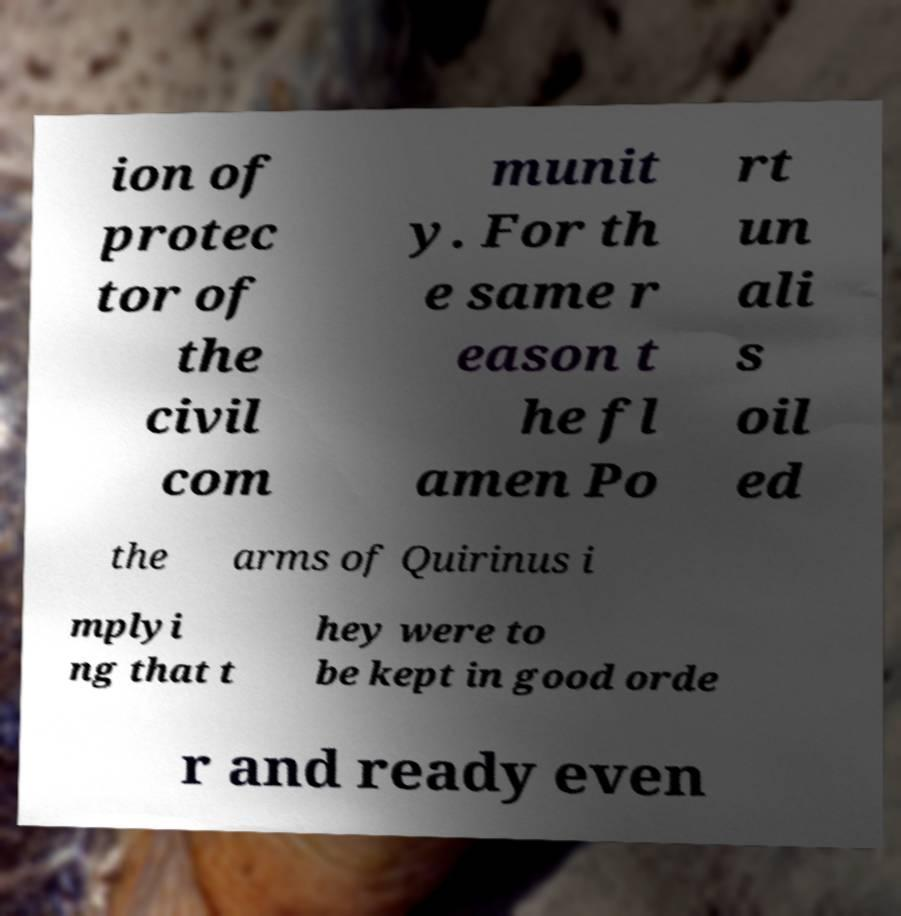Could you extract and type out the text from this image? ion of protec tor of the civil com munit y. For th e same r eason t he fl amen Po rt un ali s oil ed the arms of Quirinus i mplyi ng that t hey were to be kept in good orde r and ready even 